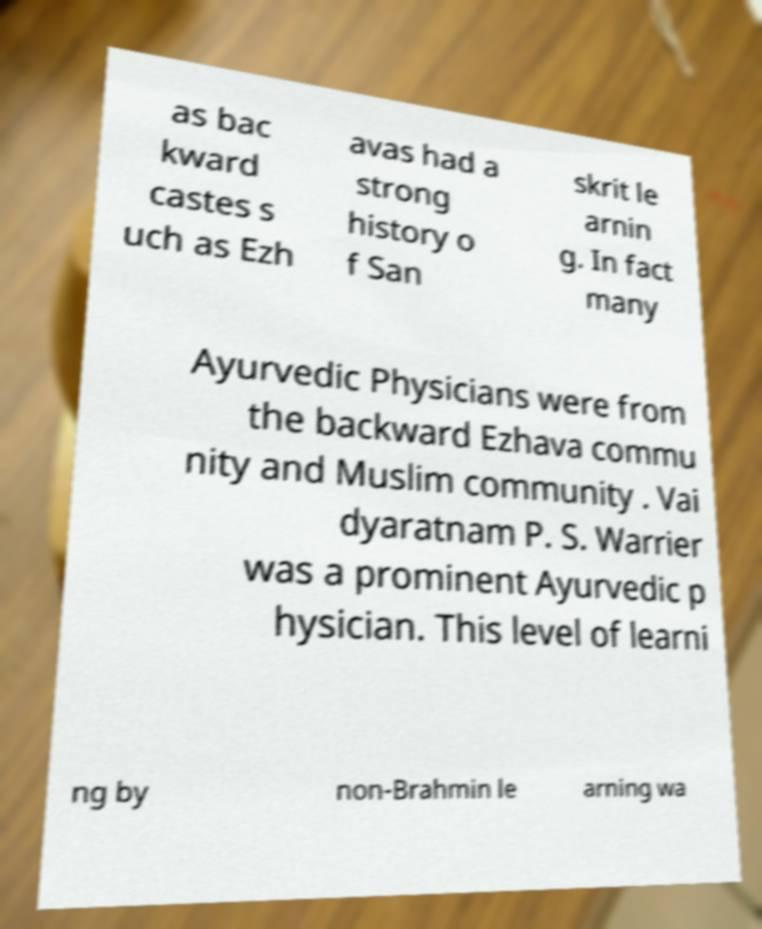Could you extract and type out the text from this image? as bac kward castes s uch as Ezh avas had a strong history o f San skrit le arnin g. In fact many Ayurvedic Physicians were from the backward Ezhava commu nity and Muslim community . Vai dyaratnam P. S. Warrier was a prominent Ayurvedic p hysician. This level of learni ng by non-Brahmin le arning wa 